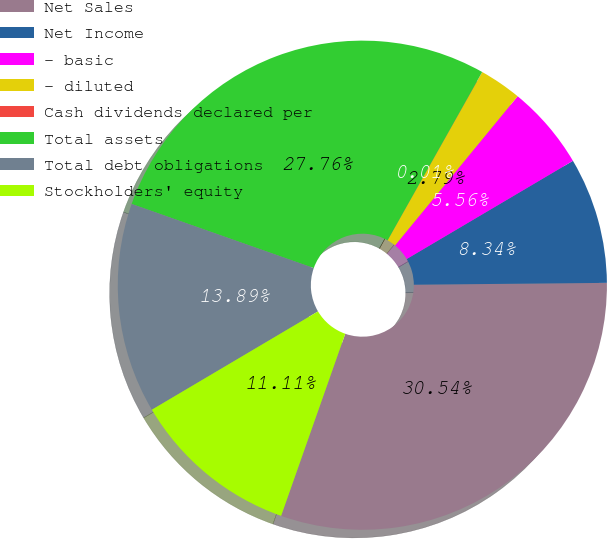Convert chart. <chart><loc_0><loc_0><loc_500><loc_500><pie_chart><fcel>Net Sales<fcel>Net Income<fcel>- basic<fcel>- diluted<fcel>Cash dividends declared per<fcel>Total assets<fcel>Total debt obligations<fcel>Stockholders' equity<nl><fcel>30.54%<fcel>8.34%<fcel>5.56%<fcel>2.79%<fcel>0.01%<fcel>27.76%<fcel>13.89%<fcel>11.11%<nl></chart> 